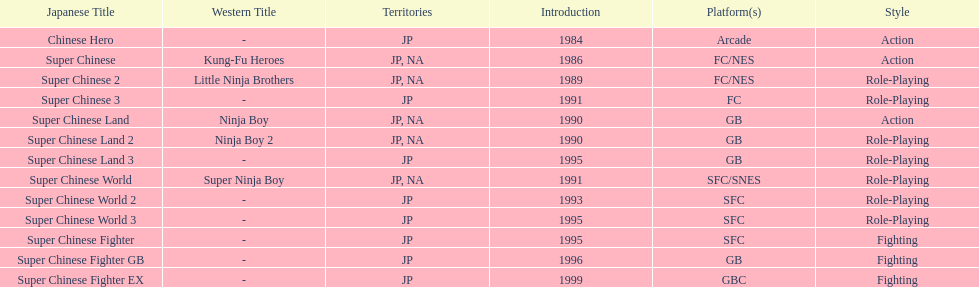Which titles were released in north america? Super Chinese, Super Chinese 2, Super Chinese Land, Super Chinese Land 2, Super Chinese World. Of those, which had the least releases? Super Chinese World. 